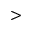Convert formula to latex. <formula><loc_0><loc_0><loc_500><loc_500>></formula> 